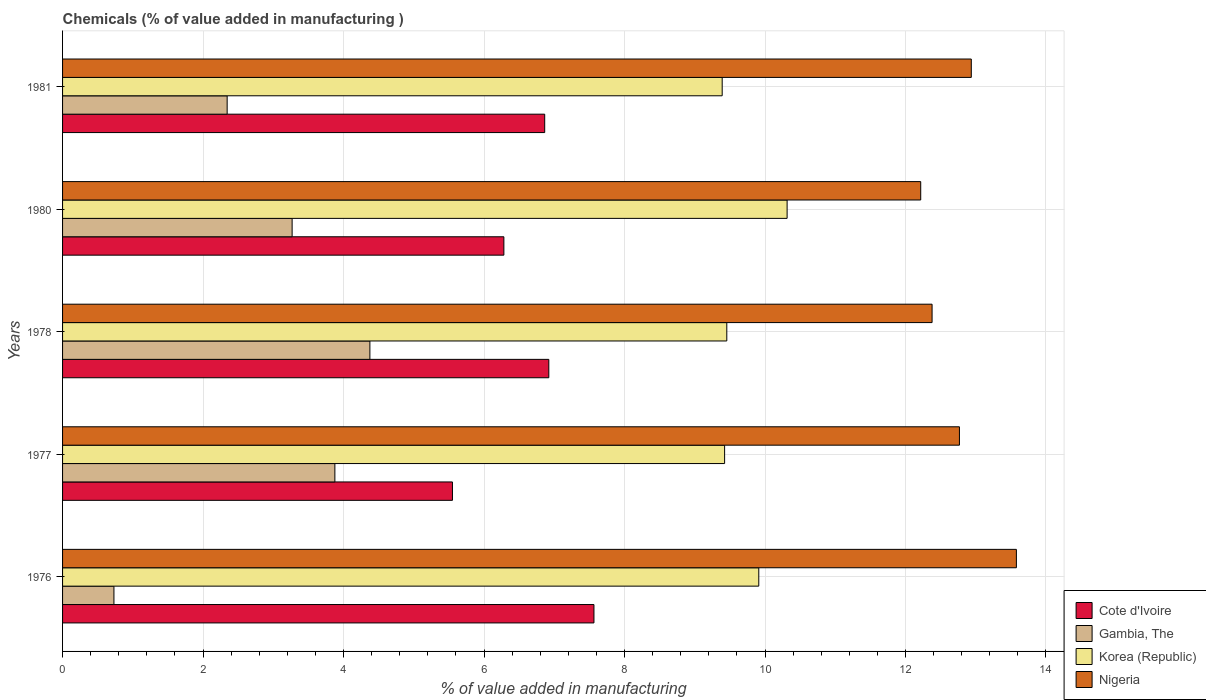How many groups of bars are there?
Give a very brief answer. 5. Are the number of bars per tick equal to the number of legend labels?
Provide a succinct answer. Yes. Are the number of bars on each tick of the Y-axis equal?
Offer a very short reply. Yes. How many bars are there on the 4th tick from the top?
Keep it short and to the point. 4. How many bars are there on the 1st tick from the bottom?
Give a very brief answer. 4. What is the value added in manufacturing chemicals in Korea (Republic) in 1978?
Make the answer very short. 9.46. Across all years, what is the maximum value added in manufacturing chemicals in Gambia, The?
Offer a very short reply. 4.38. Across all years, what is the minimum value added in manufacturing chemicals in Korea (Republic)?
Your answer should be compact. 9.39. In which year was the value added in manufacturing chemicals in Nigeria maximum?
Your answer should be very brief. 1976. In which year was the value added in manufacturing chemicals in Korea (Republic) minimum?
Make the answer very short. 1981. What is the total value added in manufacturing chemicals in Cote d'Ivoire in the graph?
Ensure brevity in your answer.  33.18. What is the difference between the value added in manufacturing chemicals in Gambia, The in 1977 and that in 1981?
Your answer should be very brief. 1.53. What is the difference between the value added in manufacturing chemicals in Nigeria in 1981 and the value added in manufacturing chemicals in Cote d'Ivoire in 1976?
Provide a short and direct response. 5.37. What is the average value added in manufacturing chemicals in Gambia, The per year?
Make the answer very short. 2.92. In the year 1977, what is the difference between the value added in manufacturing chemicals in Gambia, The and value added in manufacturing chemicals in Korea (Republic)?
Offer a terse response. -5.55. In how many years, is the value added in manufacturing chemicals in Cote d'Ivoire greater than 9.2 %?
Ensure brevity in your answer.  0. What is the ratio of the value added in manufacturing chemicals in Gambia, The in 1977 to that in 1980?
Ensure brevity in your answer.  1.19. Is the value added in manufacturing chemicals in Cote d'Ivoire in 1978 less than that in 1980?
Give a very brief answer. No. What is the difference between the highest and the second highest value added in manufacturing chemicals in Korea (Republic)?
Make the answer very short. 0.4. What is the difference between the highest and the lowest value added in manufacturing chemicals in Nigeria?
Your answer should be compact. 1.36. Is the sum of the value added in manufacturing chemicals in Cote d'Ivoire in 1976 and 1981 greater than the maximum value added in manufacturing chemicals in Nigeria across all years?
Make the answer very short. Yes. What does the 1st bar from the top in 1980 represents?
Provide a short and direct response. Nigeria. What does the 4th bar from the bottom in 1978 represents?
Provide a succinct answer. Nigeria. How many bars are there?
Provide a succinct answer. 20. How many years are there in the graph?
Offer a terse response. 5. What is the difference between two consecutive major ticks on the X-axis?
Give a very brief answer. 2. Does the graph contain grids?
Provide a succinct answer. Yes. How are the legend labels stacked?
Provide a succinct answer. Vertical. What is the title of the graph?
Offer a very short reply. Chemicals (% of value added in manufacturing ). Does "Somalia" appear as one of the legend labels in the graph?
Offer a terse response. No. What is the label or title of the X-axis?
Offer a very short reply. % of value added in manufacturing. What is the label or title of the Y-axis?
Provide a succinct answer. Years. What is the % of value added in manufacturing of Cote d'Ivoire in 1976?
Keep it short and to the point. 7.56. What is the % of value added in manufacturing in Gambia, The in 1976?
Your answer should be very brief. 0.73. What is the % of value added in manufacturing in Korea (Republic) in 1976?
Provide a succinct answer. 9.91. What is the % of value added in manufacturing of Nigeria in 1976?
Give a very brief answer. 13.58. What is the % of value added in manufacturing in Cote d'Ivoire in 1977?
Your answer should be compact. 5.55. What is the % of value added in manufacturing in Gambia, The in 1977?
Ensure brevity in your answer.  3.88. What is the % of value added in manufacturing in Korea (Republic) in 1977?
Offer a very short reply. 9.42. What is the % of value added in manufacturing in Nigeria in 1977?
Give a very brief answer. 12.77. What is the % of value added in manufacturing of Cote d'Ivoire in 1978?
Provide a short and direct response. 6.92. What is the % of value added in manufacturing of Gambia, The in 1978?
Ensure brevity in your answer.  4.38. What is the % of value added in manufacturing in Korea (Republic) in 1978?
Keep it short and to the point. 9.46. What is the % of value added in manufacturing of Nigeria in 1978?
Offer a very short reply. 12.38. What is the % of value added in manufacturing of Cote d'Ivoire in 1980?
Give a very brief answer. 6.28. What is the % of value added in manufacturing of Gambia, The in 1980?
Offer a very short reply. 3.27. What is the % of value added in manufacturing in Korea (Republic) in 1980?
Offer a very short reply. 10.31. What is the % of value added in manufacturing of Nigeria in 1980?
Your answer should be very brief. 12.22. What is the % of value added in manufacturing of Cote d'Ivoire in 1981?
Provide a succinct answer. 6.86. What is the % of value added in manufacturing in Gambia, The in 1981?
Ensure brevity in your answer.  2.34. What is the % of value added in manufacturing in Korea (Republic) in 1981?
Keep it short and to the point. 9.39. What is the % of value added in manufacturing of Nigeria in 1981?
Offer a terse response. 12.94. Across all years, what is the maximum % of value added in manufacturing of Cote d'Ivoire?
Provide a short and direct response. 7.56. Across all years, what is the maximum % of value added in manufacturing of Gambia, The?
Your answer should be very brief. 4.38. Across all years, what is the maximum % of value added in manufacturing of Korea (Republic)?
Provide a short and direct response. 10.31. Across all years, what is the maximum % of value added in manufacturing in Nigeria?
Ensure brevity in your answer.  13.58. Across all years, what is the minimum % of value added in manufacturing in Cote d'Ivoire?
Make the answer very short. 5.55. Across all years, what is the minimum % of value added in manufacturing in Gambia, The?
Make the answer very short. 0.73. Across all years, what is the minimum % of value added in manufacturing in Korea (Republic)?
Offer a terse response. 9.39. Across all years, what is the minimum % of value added in manufacturing in Nigeria?
Offer a very short reply. 12.22. What is the total % of value added in manufacturing in Cote d'Ivoire in the graph?
Ensure brevity in your answer.  33.18. What is the total % of value added in manufacturing of Gambia, The in the graph?
Ensure brevity in your answer.  14.59. What is the total % of value added in manufacturing of Korea (Republic) in the graph?
Your response must be concise. 48.5. What is the total % of value added in manufacturing of Nigeria in the graph?
Provide a succinct answer. 63.88. What is the difference between the % of value added in manufacturing in Cote d'Ivoire in 1976 and that in 1977?
Keep it short and to the point. 2.01. What is the difference between the % of value added in manufacturing of Gambia, The in 1976 and that in 1977?
Your response must be concise. -3.15. What is the difference between the % of value added in manufacturing of Korea (Republic) in 1976 and that in 1977?
Make the answer very short. 0.49. What is the difference between the % of value added in manufacturing of Nigeria in 1976 and that in 1977?
Give a very brief answer. 0.81. What is the difference between the % of value added in manufacturing in Cote d'Ivoire in 1976 and that in 1978?
Your answer should be very brief. 0.64. What is the difference between the % of value added in manufacturing in Gambia, The in 1976 and that in 1978?
Make the answer very short. -3.64. What is the difference between the % of value added in manufacturing in Korea (Republic) in 1976 and that in 1978?
Provide a short and direct response. 0.46. What is the difference between the % of value added in manufacturing in Nigeria in 1976 and that in 1978?
Offer a terse response. 1.2. What is the difference between the % of value added in manufacturing of Cote d'Ivoire in 1976 and that in 1980?
Make the answer very short. 1.28. What is the difference between the % of value added in manufacturing in Gambia, The in 1976 and that in 1980?
Your response must be concise. -2.54. What is the difference between the % of value added in manufacturing of Korea (Republic) in 1976 and that in 1980?
Your answer should be very brief. -0.4. What is the difference between the % of value added in manufacturing in Nigeria in 1976 and that in 1980?
Give a very brief answer. 1.36. What is the difference between the % of value added in manufacturing in Cote d'Ivoire in 1976 and that in 1981?
Ensure brevity in your answer.  0.7. What is the difference between the % of value added in manufacturing in Gambia, The in 1976 and that in 1981?
Provide a short and direct response. -1.61. What is the difference between the % of value added in manufacturing of Korea (Republic) in 1976 and that in 1981?
Provide a short and direct response. 0.52. What is the difference between the % of value added in manufacturing of Nigeria in 1976 and that in 1981?
Your response must be concise. 0.64. What is the difference between the % of value added in manufacturing of Cote d'Ivoire in 1977 and that in 1978?
Provide a succinct answer. -1.37. What is the difference between the % of value added in manufacturing of Gambia, The in 1977 and that in 1978?
Your response must be concise. -0.5. What is the difference between the % of value added in manufacturing of Korea (Republic) in 1977 and that in 1978?
Your answer should be very brief. -0.03. What is the difference between the % of value added in manufacturing in Nigeria in 1977 and that in 1978?
Keep it short and to the point. 0.39. What is the difference between the % of value added in manufacturing of Cote d'Ivoire in 1977 and that in 1980?
Make the answer very short. -0.73. What is the difference between the % of value added in manufacturing of Gambia, The in 1977 and that in 1980?
Give a very brief answer. 0.61. What is the difference between the % of value added in manufacturing in Korea (Republic) in 1977 and that in 1980?
Offer a terse response. -0.89. What is the difference between the % of value added in manufacturing of Nigeria in 1977 and that in 1980?
Your response must be concise. 0.55. What is the difference between the % of value added in manufacturing in Cote d'Ivoire in 1977 and that in 1981?
Your answer should be compact. -1.31. What is the difference between the % of value added in manufacturing of Gambia, The in 1977 and that in 1981?
Ensure brevity in your answer.  1.53. What is the difference between the % of value added in manufacturing in Korea (Republic) in 1977 and that in 1981?
Your answer should be very brief. 0.03. What is the difference between the % of value added in manufacturing of Nigeria in 1977 and that in 1981?
Provide a short and direct response. -0.17. What is the difference between the % of value added in manufacturing in Cote d'Ivoire in 1978 and that in 1980?
Make the answer very short. 0.64. What is the difference between the % of value added in manufacturing of Gambia, The in 1978 and that in 1980?
Your answer should be compact. 1.11. What is the difference between the % of value added in manufacturing in Korea (Republic) in 1978 and that in 1980?
Make the answer very short. -0.86. What is the difference between the % of value added in manufacturing in Nigeria in 1978 and that in 1980?
Keep it short and to the point. 0.16. What is the difference between the % of value added in manufacturing of Cote d'Ivoire in 1978 and that in 1981?
Provide a succinct answer. 0.06. What is the difference between the % of value added in manufacturing in Gambia, The in 1978 and that in 1981?
Ensure brevity in your answer.  2.03. What is the difference between the % of value added in manufacturing of Korea (Republic) in 1978 and that in 1981?
Keep it short and to the point. 0.07. What is the difference between the % of value added in manufacturing of Nigeria in 1978 and that in 1981?
Your answer should be very brief. -0.56. What is the difference between the % of value added in manufacturing in Cote d'Ivoire in 1980 and that in 1981?
Keep it short and to the point. -0.58. What is the difference between the % of value added in manufacturing of Gambia, The in 1980 and that in 1981?
Provide a succinct answer. 0.92. What is the difference between the % of value added in manufacturing of Korea (Republic) in 1980 and that in 1981?
Offer a terse response. 0.92. What is the difference between the % of value added in manufacturing of Nigeria in 1980 and that in 1981?
Offer a terse response. -0.72. What is the difference between the % of value added in manufacturing of Cote d'Ivoire in 1976 and the % of value added in manufacturing of Gambia, The in 1977?
Provide a short and direct response. 3.69. What is the difference between the % of value added in manufacturing in Cote d'Ivoire in 1976 and the % of value added in manufacturing in Korea (Republic) in 1977?
Make the answer very short. -1.86. What is the difference between the % of value added in manufacturing in Cote d'Ivoire in 1976 and the % of value added in manufacturing in Nigeria in 1977?
Provide a short and direct response. -5.2. What is the difference between the % of value added in manufacturing of Gambia, The in 1976 and the % of value added in manufacturing of Korea (Republic) in 1977?
Your response must be concise. -8.69. What is the difference between the % of value added in manufacturing in Gambia, The in 1976 and the % of value added in manufacturing in Nigeria in 1977?
Keep it short and to the point. -12.04. What is the difference between the % of value added in manufacturing in Korea (Republic) in 1976 and the % of value added in manufacturing in Nigeria in 1977?
Provide a short and direct response. -2.86. What is the difference between the % of value added in manufacturing in Cote d'Ivoire in 1976 and the % of value added in manufacturing in Gambia, The in 1978?
Provide a succinct answer. 3.19. What is the difference between the % of value added in manufacturing in Cote d'Ivoire in 1976 and the % of value added in manufacturing in Korea (Republic) in 1978?
Provide a short and direct response. -1.89. What is the difference between the % of value added in manufacturing of Cote d'Ivoire in 1976 and the % of value added in manufacturing of Nigeria in 1978?
Provide a short and direct response. -4.81. What is the difference between the % of value added in manufacturing of Gambia, The in 1976 and the % of value added in manufacturing of Korea (Republic) in 1978?
Give a very brief answer. -8.72. What is the difference between the % of value added in manufacturing in Gambia, The in 1976 and the % of value added in manufacturing in Nigeria in 1978?
Offer a very short reply. -11.65. What is the difference between the % of value added in manufacturing in Korea (Republic) in 1976 and the % of value added in manufacturing in Nigeria in 1978?
Provide a succinct answer. -2.47. What is the difference between the % of value added in manufacturing of Cote d'Ivoire in 1976 and the % of value added in manufacturing of Gambia, The in 1980?
Give a very brief answer. 4.3. What is the difference between the % of value added in manufacturing in Cote d'Ivoire in 1976 and the % of value added in manufacturing in Korea (Republic) in 1980?
Provide a short and direct response. -2.75. What is the difference between the % of value added in manufacturing of Cote d'Ivoire in 1976 and the % of value added in manufacturing of Nigeria in 1980?
Ensure brevity in your answer.  -4.65. What is the difference between the % of value added in manufacturing of Gambia, The in 1976 and the % of value added in manufacturing of Korea (Republic) in 1980?
Keep it short and to the point. -9.58. What is the difference between the % of value added in manufacturing of Gambia, The in 1976 and the % of value added in manufacturing of Nigeria in 1980?
Provide a succinct answer. -11.49. What is the difference between the % of value added in manufacturing in Korea (Republic) in 1976 and the % of value added in manufacturing in Nigeria in 1980?
Offer a terse response. -2.31. What is the difference between the % of value added in manufacturing of Cote d'Ivoire in 1976 and the % of value added in manufacturing of Gambia, The in 1981?
Give a very brief answer. 5.22. What is the difference between the % of value added in manufacturing in Cote d'Ivoire in 1976 and the % of value added in manufacturing in Korea (Republic) in 1981?
Your answer should be very brief. -1.83. What is the difference between the % of value added in manufacturing of Cote d'Ivoire in 1976 and the % of value added in manufacturing of Nigeria in 1981?
Make the answer very short. -5.37. What is the difference between the % of value added in manufacturing in Gambia, The in 1976 and the % of value added in manufacturing in Korea (Republic) in 1981?
Provide a short and direct response. -8.66. What is the difference between the % of value added in manufacturing of Gambia, The in 1976 and the % of value added in manufacturing of Nigeria in 1981?
Offer a very short reply. -12.21. What is the difference between the % of value added in manufacturing in Korea (Republic) in 1976 and the % of value added in manufacturing in Nigeria in 1981?
Your response must be concise. -3.03. What is the difference between the % of value added in manufacturing in Cote d'Ivoire in 1977 and the % of value added in manufacturing in Gambia, The in 1978?
Provide a succinct answer. 1.18. What is the difference between the % of value added in manufacturing of Cote d'Ivoire in 1977 and the % of value added in manufacturing of Korea (Republic) in 1978?
Offer a very short reply. -3.91. What is the difference between the % of value added in manufacturing of Cote d'Ivoire in 1977 and the % of value added in manufacturing of Nigeria in 1978?
Provide a short and direct response. -6.83. What is the difference between the % of value added in manufacturing of Gambia, The in 1977 and the % of value added in manufacturing of Korea (Republic) in 1978?
Offer a very short reply. -5.58. What is the difference between the % of value added in manufacturing in Gambia, The in 1977 and the % of value added in manufacturing in Nigeria in 1978?
Give a very brief answer. -8.5. What is the difference between the % of value added in manufacturing of Korea (Republic) in 1977 and the % of value added in manufacturing of Nigeria in 1978?
Your response must be concise. -2.95. What is the difference between the % of value added in manufacturing of Cote d'Ivoire in 1977 and the % of value added in manufacturing of Gambia, The in 1980?
Provide a short and direct response. 2.28. What is the difference between the % of value added in manufacturing of Cote d'Ivoire in 1977 and the % of value added in manufacturing of Korea (Republic) in 1980?
Provide a succinct answer. -4.76. What is the difference between the % of value added in manufacturing of Cote d'Ivoire in 1977 and the % of value added in manufacturing of Nigeria in 1980?
Ensure brevity in your answer.  -6.67. What is the difference between the % of value added in manufacturing in Gambia, The in 1977 and the % of value added in manufacturing in Korea (Republic) in 1980?
Offer a very short reply. -6.44. What is the difference between the % of value added in manufacturing of Gambia, The in 1977 and the % of value added in manufacturing of Nigeria in 1980?
Offer a very short reply. -8.34. What is the difference between the % of value added in manufacturing in Korea (Republic) in 1977 and the % of value added in manufacturing in Nigeria in 1980?
Your answer should be very brief. -2.79. What is the difference between the % of value added in manufacturing in Cote d'Ivoire in 1977 and the % of value added in manufacturing in Gambia, The in 1981?
Make the answer very short. 3.21. What is the difference between the % of value added in manufacturing of Cote d'Ivoire in 1977 and the % of value added in manufacturing of Korea (Republic) in 1981?
Your answer should be very brief. -3.84. What is the difference between the % of value added in manufacturing in Cote d'Ivoire in 1977 and the % of value added in manufacturing in Nigeria in 1981?
Keep it short and to the point. -7.39. What is the difference between the % of value added in manufacturing in Gambia, The in 1977 and the % of value added in manufacturing in Korea (Republic) in 1981?
Your response must be concise. -5.51. What is the difference between the % of value added in manufacturing in Gambia, The in 1977 and the % of value added in manufacturing in Nigeria in 1981?
Ensure brevity in your answer.  -9.06. What is the difference between the % of value added in manufacturing of Korea (Republic) in 1977 and the % of value added in manufacturing of Nigeria in 1981?
Offer a very short reply. -3.51. What is the difference between the % of value added in manufacturing of Cote d'Ivoire in 1978 and the % of value added in manufacturing of Gambia, The in 1980?
Offer a very short reply. 3.65. What is the difference between the % of value added in manufacturing in Cote d'Ivoire in 1978 and the % of value added in manufacturing in Korea (Republic) in 1980?
Provide a short and direct response. -3.39. What is the difference between the % of value added in manufacturing in Cote d'Ivoire in 1978 and the % of value added in manufacturing in Nigeria in 1980?
Your answer should be compact. -5.29. What is the difference between the % of value added in manufacturing in Gambia, The in 1978 and the % of value added in manufacturing in Korea (Republic) in 1980?
Your answer should be compact. -5.94. What is the difference between the % of value added in manufacturing in Gambia, The in 1978 and the % of value added in manufacturing in Nigeria in 1980?
Provide a short and direct response. -7.84. What is the difference between the % of value added in manufacturing of Korea (Republic) in 1978 and the % of value added in manufacturing of Nigeria in 1980?
Provide a short and direct response. -2.76. What is the difference between the % of value added in manufacturing of Cote d'Ivoire in 1978 and the % of value added in manufacturing of Gambia, The in 1981?
Your response must be concise. 4.58. What is the difference between the % of value added in manufacturing of Cote d'Ivoire in 1978 and the % of value added in manufacturing of Korea (Republic) in 1981?
Provide a succinct answer. -2.47. What is the difference between the % of value added in manufacturing of Cote d'Ivoire in 1978 and the % of value added in manufacturing of Nigeria in 1981?
Your answer should be compact. -6.01. What is the difference between the % of value added in manufacturing in Gambia, The in 1978 and the % of value added in manufacturing in Korea (Republic) in 1981?
Give a very brief answer. -5.02. What is the difference between the % of value added in manufacturing in Gambia, The in 1978 and the % of value added in manufacturing in Nigeria in 1981?
Provide a short and direct response. -8.56. What is the difference between the % of value added in manufacturing in Korea (Republic) in 1978 and the % of value added in manufacturing in Nigeria in 1981?
Offer a terse response. -3.48. What is the difference between the % of value added in manufacturing in Cote d'Ivoire in 1980 and the % of value added in manufacturing in Gambia, The in 1981?
Provide a short and direct response. 3.94. What is the difference between the % of value added in manufacturing of Cote d'Ivoire in 1980 and the % of value added in manufacturing of Korea (Republic) in 1981?
Make the answer very short. -3.11. What is the difference between the % of value added in manufacturing in Cote d'Ivoire in 1980 and the % of value added in manufacturing in Nigeria in 1981?
Ensure brevity in your answer.  -6.65. What is the difference between the % of value added in manufacturing in Gambia, The in 1980 and the % of value added in manufacturing in Korea (Republic) in 1981?
Your answer should be compact. -6.12. What is the difference between the % of value added in manufacturing in Gambia, The in 1980 and the % of value added in manufacturing in Nigeria in 1981?
Give a very brief answer. -9.67. What is the difference between the % of value added in manufacturing of Korea (Republic) in 1980 and the % of value added in manufacturing of Nigeria in 1981?
Ensure brevity in your answer.  -2.62. What is the average % of value added in manufacturing in Cote d'Ivoire per year?
Give a very brief answer. 6.64. What is the average % of value added in manufacturing in Gambia, The per year?
Keep it short and to the point. 2.92. What is the average % of value added in manufacturing of Korea (Republic) per year?
Give a very brief answer. 9.7. What is the average % of value added in manufacturing of Nigeria per year?
Your response must be concise. 12.78. In the year 1976, what is the difference between the % of value added in manufacturing of Cote d'Ivoire and % of value added in manufacturing of Gambia, The?
Keep it short and to the point. 6.83. In the year 1976, what is the difference between the % of value added in manufacturing of Cote d'Ivoire and % of value added in manufacturing of Korea (Republic)?
Provide a short and direct response. -2.35. In the year 1976, what is the difference between the % of value added in manufacturing in Cote d'Ivoire and % of value added in manufacturing in Nigeria?
Provide a short and direct response. -6.01. In the year 1976, what is the difference between the % of value added in manufacturing of Gambia, The and % of value added in manufacturing of Korea (Republic)?
Offer a terse response. -9.18. In the year 1976, what is the difference between the % of value added in manufacturing of Gambia, The and % of value added in manufacturing of Nigeria?
Your answer should be compact. -12.85. In the year 1976, what is the difference between the % of value added in manufacturing in Korea (Republic) and % of value added in manufacturing in Nigeria?
Keep it short and to the point. -3.67. In the year 1977, what is the difference between the % of value added in manufacturing of Cote d'Ivoire and % of value added in manufacturing of Gambia, The?
Your answer should be compact. 1.67. In the year 1977, what is the difference between the % of value added in manufacturing of Cote d'Ivoire and % of value added in manufacturing of Korea (Republic)?
Your answer should be very brief. -3.87. In the year 1977, what is the difference between the % of value added in manufacturing of Cote d'Ivoire and % of value added in manufacturing of Nigeria?
Your response must be concise. -7.22. In the year 1977, what is the difference between the % of value added in manufacturing of Gambia, The and % of value added in manufacturing of Korea (Republic)?
Keep it short and to the point. -5.55. In the year 1977, what is the difference between the % of value added in manufacturing of Gambia, The and % of value added in manufacturing of Nigeria?
Provide a succinct answer. -8.89. In the year 1977, what is the difference between the % of value added in manufacturing of Korea (Republic) and % of value added in manufacturing of Nigeria?
Offer a terse response. -3.34. In the year 1978, what is the difference between the % of value added in manufacturing of Cote d'Ivoire and % of value added in manufacturing of Gambia, The?
Your answer should be very brief. 2.55. In the year 1978, what is the difference between the % of value added in manufacturing of Cote d'Ivoire and % of value added in manufacturing of Korea (Republic)?
Provide a succinct answer. -2.53. In the year 1978, what is the difference between the % of value added in manufacturing in Cote d'Ivoire and % of value added in manufacturing in Nigeria?
Provide a succinct answer. -5.46. In the year 1978, what is the difference between the % of value added in manufacturing of Gambia, The and % of value added in manufacturing of Korea (Republic)?
Offer a terse response. -5.08. In the year 1978, what is the difference between the % of value added in manufacturing in Gambia, The and % of value added in manufacturing in Nigeria?
Offer a very short reply. -8. In the year 1978, what is the difference between the % of value added in manufacturing of Korea (Republic) and % of value added in manufacturing of Nigeria?
Provide a succinct answer. -2.92. In the year 1980, what is the difference between the % of value added in manufacturing of Cote d'Ivoire and % of value added in manufacturing of Gambia, The?
Offer a terse response. 3.01. In the year 1980, what is the difference between the % of value added in manufacturing in Cote d'Ivoire and % of value added in manufacturing in Korea (Republic)?
Your answer should be very brief. -4.03. In the year 1980, what is the difference between the % of value added in manufacturing in Cote d'Ivoire and % of value added in manufacturing in Nigeria?
Provide a succinct answer. -5.93. In the year 1980, what is the difference between the % of value added in manufacturing of Gambia, The and % of value added in manufacturing of Korea (Republic)?
Provide a short and direct response. -7.05. In the year 1980, what is the difference between the % of value added in manufacturing of Gambia, The and % of value added in manufacturing of Nigeria?
Provide a succinct answer. -8.95. In the year 1980, what is the difference between the % of value added in manufacturing of Korea (Republic) and % of value added in manufacturing of Nigeria?
Ensure brevity in your answer.  -1.9. In the year 1981, what is the difference between the % of value added in manufacturing in Cote d'Ivoire and % of value added in manufacturing in Gambia, The?
Give a very brief answer. 4.52. In the year 1981, what is the difference between the % of value added in manufacturing in Cote d'Ivoire and % of value added in manufacturing in Korea (Republic)?
Provide a short and direct response. -2.53. In the year 1981, what is the difference between the % of value added in manufacturing of Cote d'Ivoire and % of value added in manufacturing of Nigeria?
Make the answer very short. -6.07. In the year 1981, what is the difference between the % of value added in manufacturing of Gambia, The and % of value added in manufacturing of Korea (Republic)?
Your answer should be compact. -7.05. In the year 1981, what is the difference between the % of value added in manufacturing in Gambia, The and % of value added in manufacturing in Nigeria?
Offer a terse response. -10.59. In the year 1981, what is the difference between the % of value added in manufacturing of Korea (Republic) and % of value added in manufacturing of Nigeria?
Provide a succinct answer. -3.55. What is the ratio of the % of value added in manufacturing in Cote d'Ivoire in 1976 to that in 1977?
Keep it short and to the point. 1.36. What is the ratio of the % of value added in manufacturing of Gambia, The in 1976 to that in 1977?
Ensure brevity in your answer.  0.19. What is the ratio of the % of value added in manufacturing of Korea (Republic) in 1976 to that in 1977?
Keep it short and to the point. 1.05. What is the ratio of the % of value added in manufacturing in Nigeria in 1976 to that in 1977?
Provide a short and direct response. 1.06. What is the ratio of the % of value added in manufacturing in Cote d'Ivoire in 1976 to that in 1978?
Make the answer very short. 1.09. What is the ratio of the % of value added in manufacturing of Gambia, The in 1976 to that in 1978?
Your answer should be compact. 0.17. What is the ratio of the % of value added in manufacturing in Korea (Republic) in 1976 to that in 1978?
Provide a short and direct response. 1.05. What is the ratio of the % of value added in manufacturing of Nigeria in 1976 to that in 1978?
Give a very brief answer. 1.1. What is the ratio of the % of value added in manufacturing of Cote d'Ivoire in 1976 to that in 1980?
Your answer should be very brief. 1.2. What is the ratio of the % of value added in manufacturing in Gambia, The in 1976 to that in 1980?
Provide a short and direct response. 0.22. What is the ratio of the % of value added in manufacturing of Korea (Republic) in 1976 to that in 1980?
Offer a very short reply. 0.96. What is the ratio of the % of value added in manufacturing in Nigeria in 1976 to that in 1980?
Your answer should be very brief. 1.11. What is the ratio of the % of value added in manufacturing of Cote d'Ivoire in 1976 to that in 1981?
Keep it short and to the point. 1.1. What is the ratio of the % of value added in manufacturing of Gambia, The in 1976 to that in 1981?
Offer a terse response. 0.31. What is the ratio of the % of value added in manufacturing of Korea (Republic) in 1976 to that in 1981?
Give a very brief answer. 1.06. What is the ratio of the % of value added in manufacturing in Nigeria in 1976 to that in 1981?
Keep it short and to the point. 1.05. What is the ratio of the % of value added in manufacturing of Cote d'Ivoire in 1977 to that in 1978?
Provide a succinct answer. 0.8. What is the ratio of the % of value added in manufacturing in Gambia, The in 1977 to that in 1978?
Offer a terse response. 0.89. What is the ratio of the % of value added in manufacturing in Korea (Republic) in 1977 to that in 1978?
Provide a short and direct response. 1. What is the ratio of the % of value added in manufacturing of Nigeria in 1977 to that in 1978?
Provide a succinct answer. 1.03. What is the ratio of the % of value added in manufacturing of Cote d'Ivoire in 1977 to that in 1980?
Make the answer very short. 0.88. What is the ratio of the % of value added in manufacturing in Gambia, The in 1977 to that in 1980?
Provide a short and direct response. 1.19. What is the ratio of the % of value added in manufacturing in Korea (Republic) in 1977 to that in 1980?
Offer a very short reply. 0.91. What is the ratio of the % of value added in manufacturing in Nigeria in 1977 to that in 1980?
Provide a short and direct response. 1.05. What is the ratio of the % of value added in manufacturing of Cote d'Ivoire in 1977 to that in 1981?
Offer a terse response. 0.81. What is the ratio of the % of value added in manufacturing in Gambia, The in 1977 to that in 1981?
Your answer should be very brief. 1.65. What is the ratio of the % of value added in manufacturing of Korea (Republic) in 1977 to that in 1981?
Your answer should be compact. 1. What is the ratio of the % of value added in manufacturing of Nigeria in 1977 to that in 1981?
Provide a succinct answer. 0.99. What is the ratio of the % of value added in manufacturing of Cote d'Ivoire in 1978 to that in 1980?
Provide a succinct answer. 1.1. What is the ratio of the % of value added in manufacturing of Gambia, The in 1978 to that in 1980?
Your answer should be compact. 1.34. What is the ratio of the % of value added in manufacturing of Korea (Republic) in 1978 to that in 1980?
Your answer should be very brief. 0.92. What is the ratio of the % of value added in manufacturing in Nigeria in 1978 to that in 1980?
Provide a succinct answer. 1.01. What is the ratio of the % of value added in manufacturing in Cote d'Ivoire in 1978 to that in 1981?
Make the answer very short. 1.01. What is the ratio of the % of value added in manufacturing in Gambia, The in 1978 to that in 1981?
Offer a terse response. 1.87. What is the ratio of the % of value added in manufacturing in Korea (Republic) in 1978 to that in 1981?
Provide a short and direct response. 1.01. What is the ratio of the % of value added in manufacturing in Nigeria in 1978 to that in 1981?
Provide a short and direct response. 0.96. What is the ratio of the % of value added in manufacturing in Cote d'Ivoire in 1980 to that in 1981?
Provide a succinct answer. 0.92. What is the ratio of the % of value added in manufacturing of Gambia, The in 1980 to that in 1981?
Provide a succinct answer. 1.39. What is the ratio of the % of value added in manufacturing of Korea (Republic) in 1980 to that in 1981?
Your response must be concise. 1.1. What is the ratio of the % of value added in manufacturing in Nigeria in 1980 to that in 1981?
Your answer should be compact. 0.94. What is the difference between the highest and the second highest % of value added in manufacturing of Cote d'Ivoire?
Give a very brief answer. 0.64. What is the difference between the highest and the second highest % of value added in manufacturing of Gambia, The?
Offer a terse response. 0.5. What is the difference between the highest and the second highest % of value added in manufacturing in Korea (Republic)?
Keep it short and to the point. 0.4. What is the difference between the highest and the second highest % of value added in manufacturing in Nigeria?
Make the answer very short. 0.64. What is the difference between the highest and the lowest % of value added in manufacturing of Cote d'Ivoire?
Your answer should be compact. 2.01. What is the difference between the highest and the lowest % of value added in manufacturing in Gambia, The?
Your response must be concise. 3.64. What is the difference between the highest and the lowest % of value added in manufacturing of Korea (Republic)?
Keep it short and to the point. 0.92. What is the difference between the highest and the lowest % of value added in manufacturing of Nigeria?
Provide a succinct answer. 1.36. 